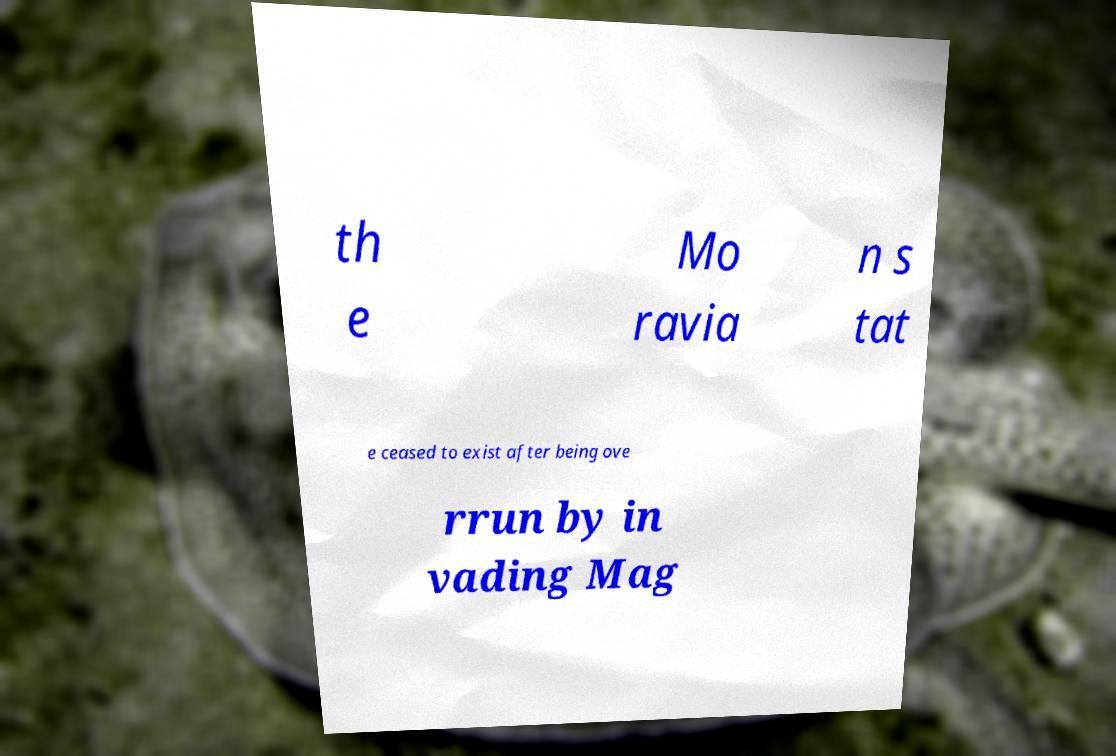Could you extract and type out the text from this image? th e Mo ravia n s tat e ceased to exist after being ove rrun by in vading Mag 